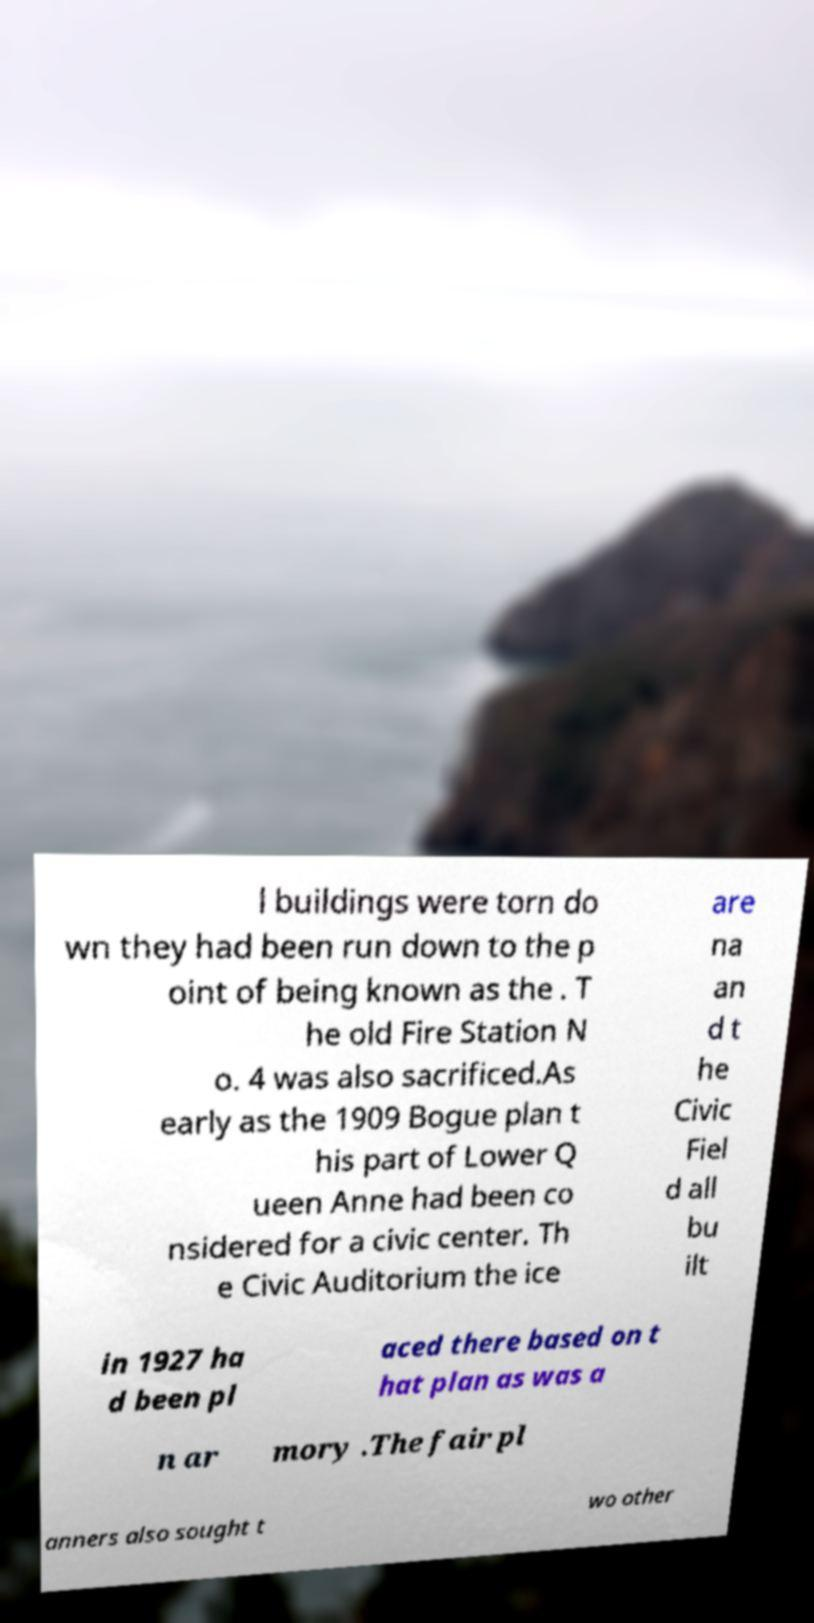What messages or text are displayed in this image? I need them in a readable, typed format. l buildings were torn do wn they had been run down to the p oint of being known as the . T he old Fire Station N o. 4 was also sacrificed.As early as the 1909 Bogue plan t his part of Lower Q ueen Anne had been co nsidered for a civic center. Th e Civic Auditorium the ice are na an d t he Civic Fiel d all bu ilt in 1927 ha d been pl aced there based on t hat plan as was a n ar mory .The fair pl anners also sought t wo other 